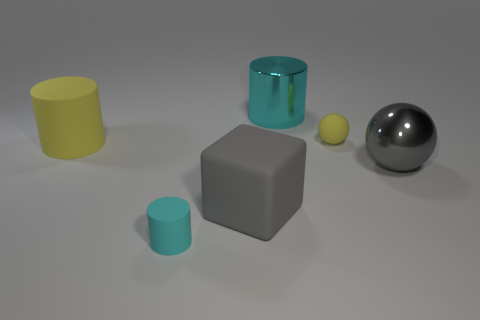The other cyan thing that is the same shape as the large cyan object is what size?
Keep it short and to the point. Small. Does the shiny cylinder behind the matte block have the same size as the block?
Provide a succinct answer. Yes. There is a sphere that is the same size as the cyan rubber cylinder; what color is it?
Ensure brevity in your answer.  Yellow. Are there any shiny things that are to the left of the yellow matte object to the right of the tiny object in front of the gray metal thing?
Provide a succinct answer. Yes. There is a large cylinder that is behind the small sphere; what material is it?
Offer a very short reply. Metal. There is a tiny yellow thing; does it have the same shape as the small thing that is in front of the big yellow object?
Give a very brief answer. No. Is the number of small cylinders behind the gray rubber thing the same as the number of yellow rubber cylinders that are on the right side of the yellow matte cylinder?
Make the answer very short. Yes. What number of other things are made of the same material as the tiny yellow thing?
Give a very brief answer. 3. What number of metal objects are either blue cylinders or big yellow objects?
Provide a short and direct response. 0. Do the large matte thing on the right side of the yellow cylinder and the large gray metal object have the same shape?
Offer a very short reply. No. 